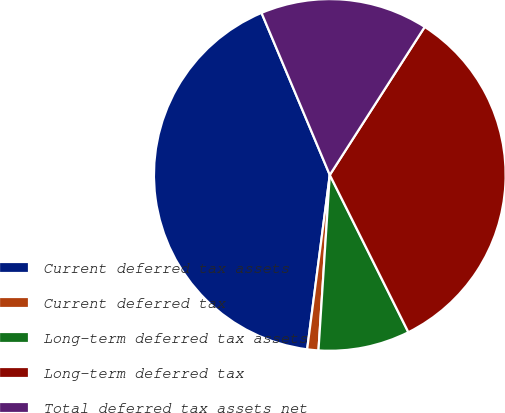Convert chart to OTSL. <chart><loc_0><loc_0><loc_500><loc_500><pie_chart><fcel>Current deferred tax assets<fcel>Current deferred tax<fcel>Long-term deferred tax assets<fcel>Long-term deferred tax<fcel>Total deferred tax assets net<nl><fcel>41.6%<fcel>1.03%<fcel>8.4%<fcel>33.55%<fcel>15.42%<nl></chart> 